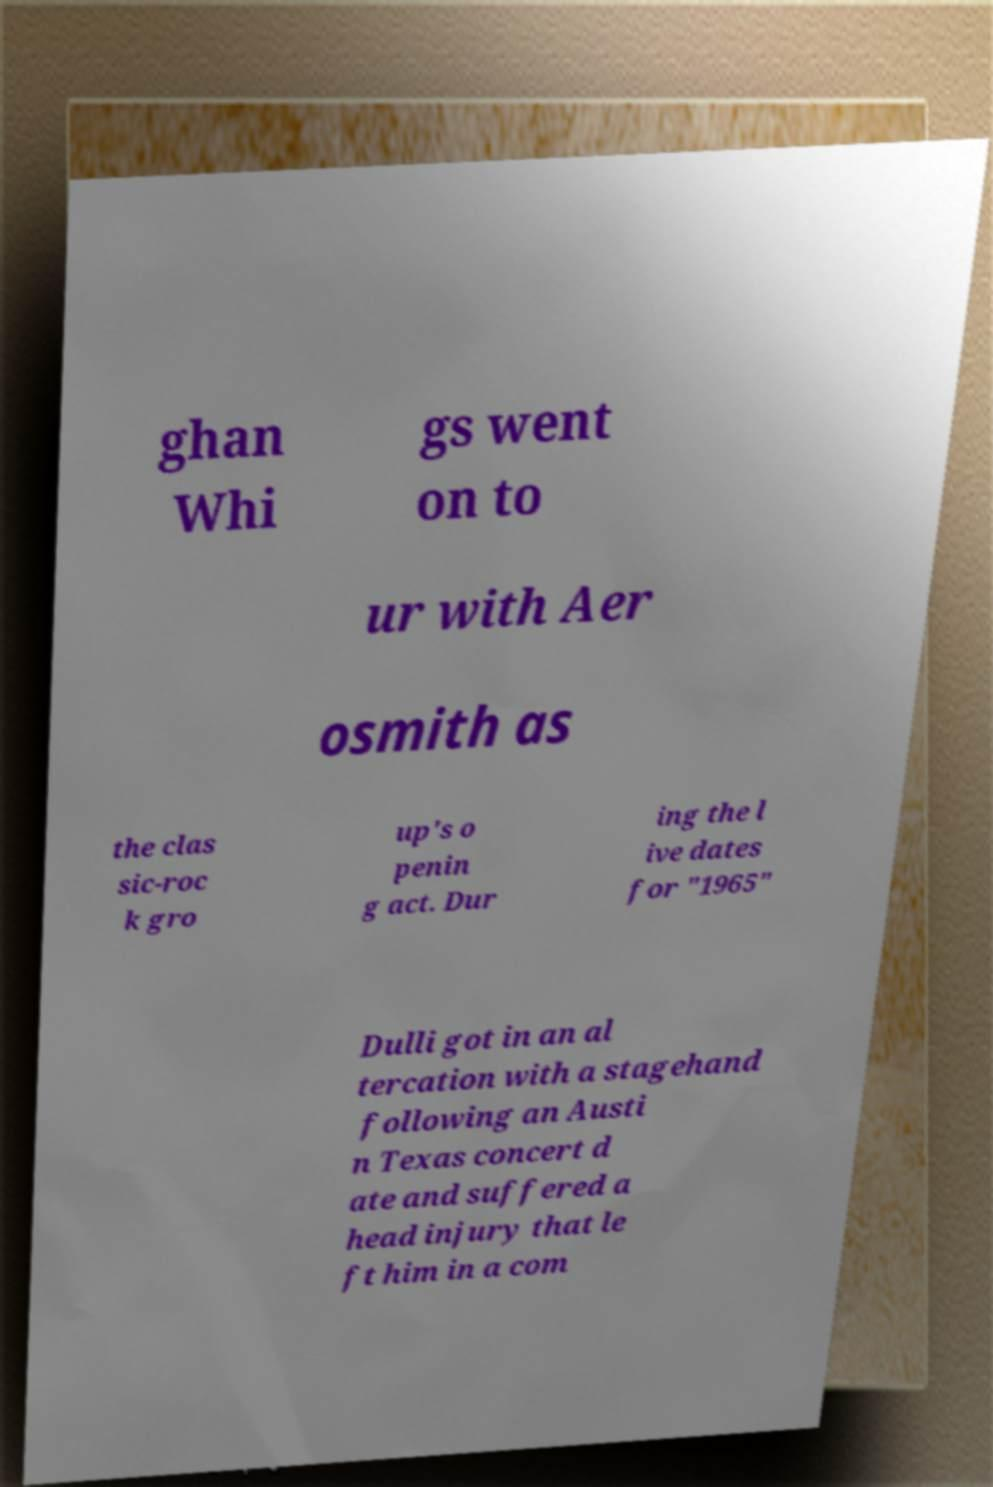I need the written content from this picture converted into text. Can you do that? ghan Whi gs went on to ur with Aer osmith as the clas sic-roc k gro up's o penin g act. Dur ing the l ive dates for "1965" Dulli got in an al tercation with a stagehand following an Austi n Texas concert d ate and suffered a head injury that le ft him in a com 